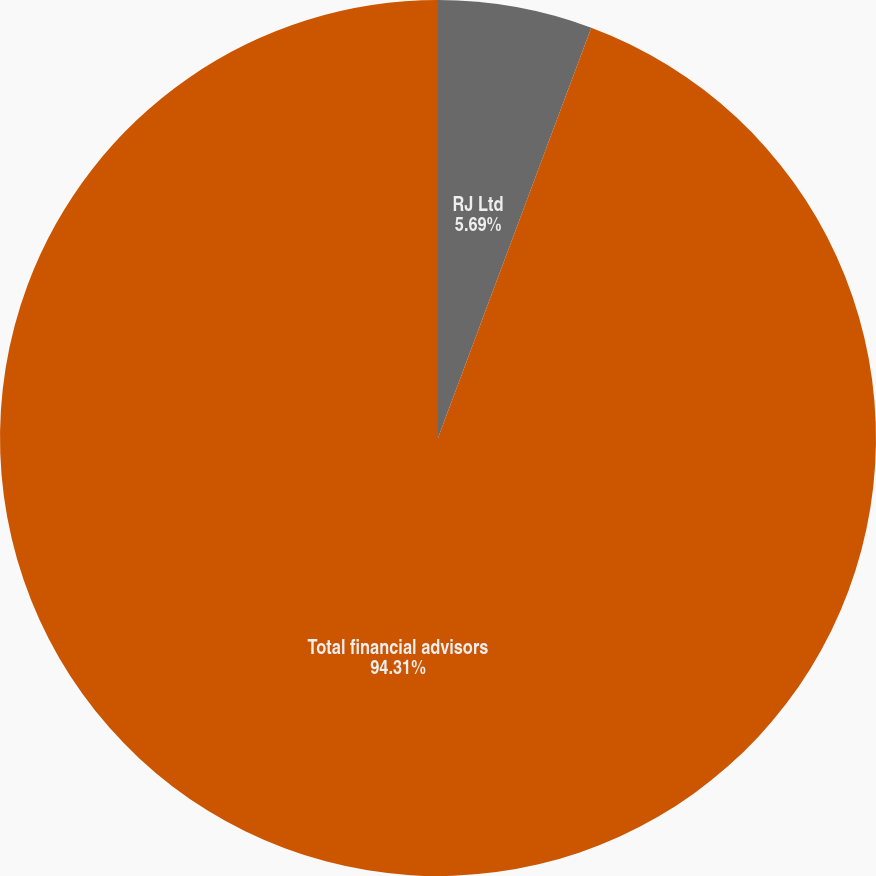Convert chart. <chart><loc_0><loc_0><loc_500><loc_500><pie_chart><fcel>RJ Ltd<fcel>Total financial advisors<nl><fcel>5.69%<fcel>94.31%<nl></chart> 